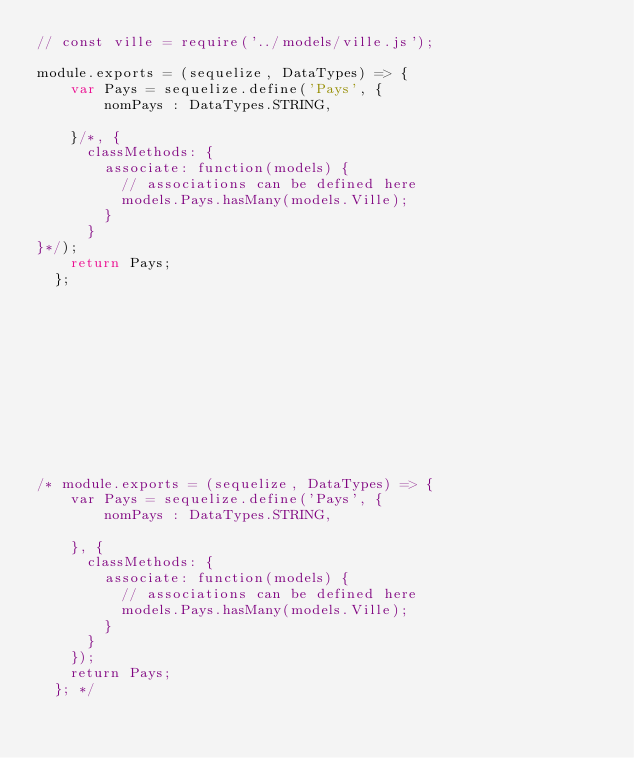Convert code to text. <code><loc_0><loc_0><loc_500><loc_500><_JavaScript_>// const ville = require('../models/ville.js');

module.exports = (sequelize, DataTypes) => {
    var Pays = sequelize.define('Pays', {
        nomPays : DataTypes.STRING,
      
    }/*, {
      classMethods: {
        associate: function(models) {
          // associations can be defined here
          models.Pays.hasMany(models.Ville);
        }
      }
}*/);
    return Pays;
  };












/* module.exports = (sequelize, DataTypes) => {
    var Pays = sequelize.define('Pays', {
        nomPays : DataTypes.STRING,
      
    }, {
      classMethods: {
        associate: function(models) {
          // associations can be defined here
          models.Pays.hasMany(models.Ville);
        }
      }
    });
    return Pays;
  }; */
</code> 